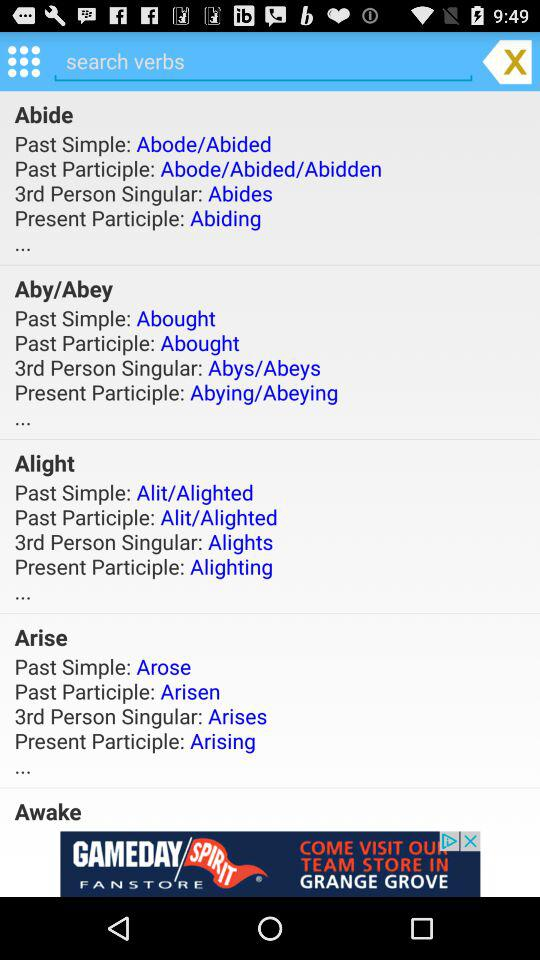What is the Past Simple of Arise? The Past Simple is "Arose". 